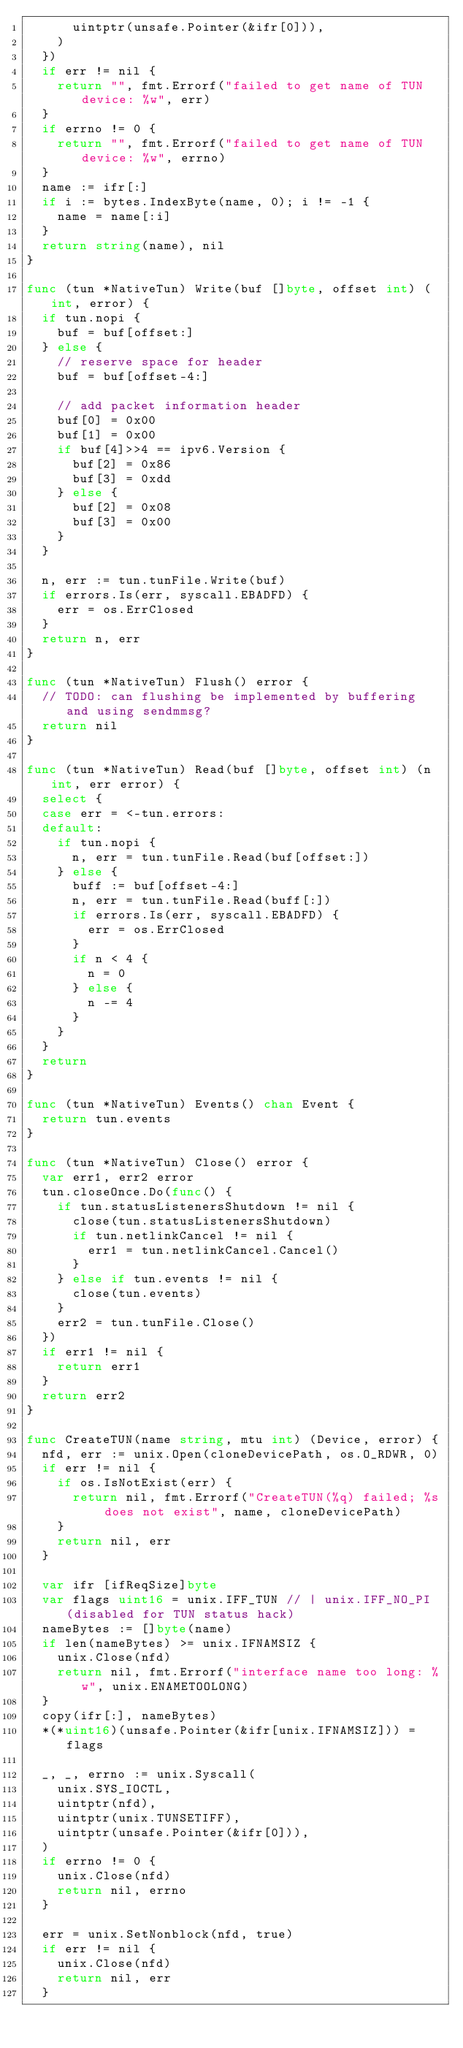Convert code to text. <code><loc_0><loc_0><loc_500><loc_500><_Go_>			uintptr(unsafe.Pointer(&ifr[0])),
		)
	})
	if err != nil {
		return "", fmt.Errorf("failed to get name of TUN device: %w", err)
	}
	if errno != 0 {
		return "", fmt.Errorf("failed to get name of TUN device: %w", errno)
	}
	name := ifr[:]
	if i := bytes.IndexByte(name, 0); i != -1 {
		name = name[:i]
	}
	return string(name), nil
}

func (tun *NativeTun) Write(buf []byte, offset int) (int, error) {
	if tun.nopi {
		buf = buf[offset:]
	} else {
		// reserve space for header
		buf = buf[offset-4:]

		// add packet information header
		buf[0] = 0x00
		buf[1] = 0x00
		if buf[4]>>4 == ipv6.Version {
			buf[2] = 0x86
			buf[3] = 0xdd
		} else {
			buf[2] = 0x08
			buf[3] = 0x00
		}
	}

	n, err := tun.tunFile.Write(buf)
	if errors.Is(err, syscall.EBADFD) {
		err = os.ErrClosed
	}
	return n, err
}

func (tun *NativeTun) Flush() error {
	// TODO: can flushing be implemented by buffering and using sendmmsg?
	return nil
}

func (tun *NativeTun) Read(buf []byte, offset int) (n int, err error) {
	select {
	case err = <-tun.errors:
	default:
		if tun.nopi {
			n, err = tun.tunFile.Read(buf[offset:])
		} else {
			buff := buf[offset-4:]
			n, err = tun.tunFile.Read(buff[:])
			if errors.Is(err, syscall.EBADFD) {
				err = os.ErrClosed
			}
			if n < 4 {
				n = 0
			} else {
				n -= 4
			}
		}
	}
	return
}

func (tun *NativeTun) Events() chan Event {
	return tun.events
}

func (tun *NativeTun) Close() error {
	var err1, err2 error
	tun.closeOnce.Do(func() {
		if tun.statusListenersShutdown != nil {
			close(tun.statusListenersShutdown)
			if tun.netlinkCancel != nil {
				err1 = tun.netlinkCancel.Cancel()
			}
		} else if tun.events != nil {
			close(tun.events)
		}
		err2 = tun.tunFile.Close()
	})
	if err1 != nil {
		return err1
	}
	return err2
}

func CreateTUN(name string, mtu int) (Device, error) {
	nfd, err := unix.Open(cloneDevicePath, os.O_RDWR, 0)
	if err != nil {
		if os.IsNotExist(err) {
			return nil, fmt.Errorf("CreateTUN(%q) failed; %s does not exist", name, cloneDevicePath)
		}
		return nil, err
	}

	var ifr [ifReqSize]byte
	var flags uint16 = unix.IFF_TUN // | unix.IFF_NO_PI (disabled for TUN status hack)
	nameBytes := []byte(name)
	if len(nameBytes) >= unix.IFNAMSIZ {
		unix.Close(nfd)
		return nil, fmt.Errorf("interface name too long: %w", unix.ENAMETOOLONG)
	}
	copy(ifr[:], nameBytes)
	*(*uint16)(unsafe.Pointer(&ifr[unix.IFNAMSIZ])) = flags

	_, _, errno := unix.Syscall(
		unix.SYS_IOCTL,
		uintptr(nfd),
		uintptr(unix.TUNSETIFF),
		uintptr(unsafe.Pointer(&ifr[0])),
	)
	if errno != 0 {
		unix.Close(nfd)
		return nil, errno
	}

	err = unix.SetNonblock(nfd, true)
	if err != nil {
		unix.Close(nfd)
		return nil, err
	}
</code> 